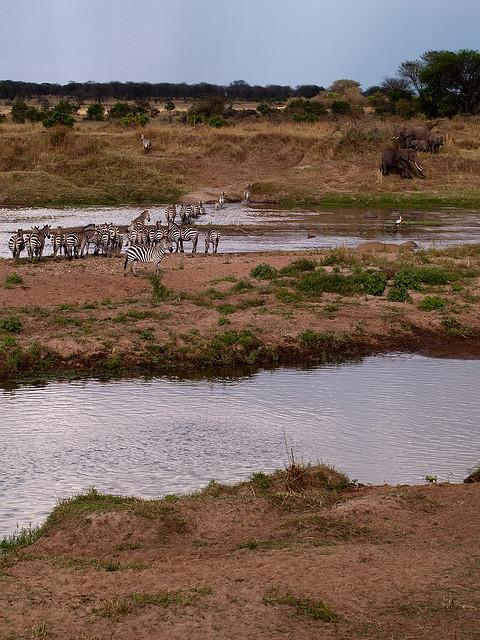How many birds are standing inside of the river with the zebras on the island?

Choices:
A) three
B) four
C) two
D) one one 